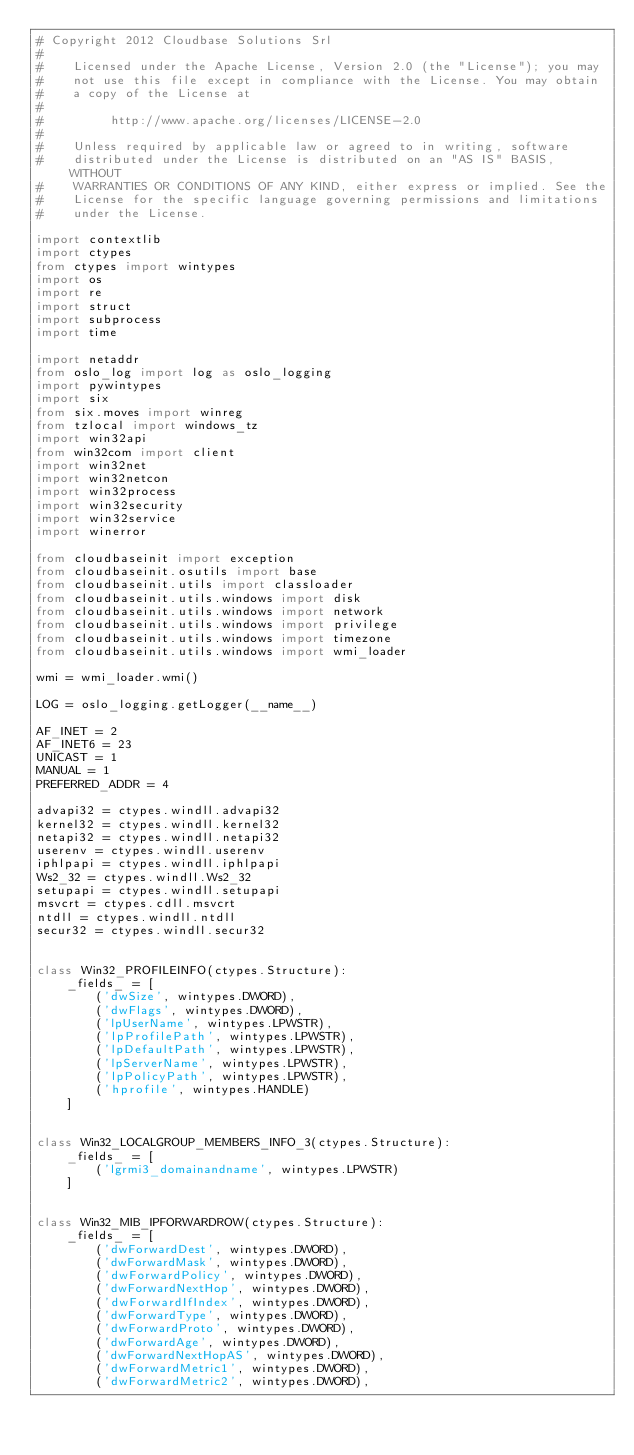<code> <loc_0><loc_0><loc_500><loc_500><_Python_># Copyright 2012 Cloudbase Solutions Srl
#
#    Licensed under the Apache License, Version 2.0 (the "License"); you may
#    not use this file except in compliance with the License. You may obtain
#    a copy of the License at
#
#         http://www.apache.org/licenses/LICENSE-2.0
#
#    Unless required by applicable law or agreed to in writing, software
#    distributed under the License is distributed on an "AS IS" BASIS, WITHOUT
#    WARRANTIES OR CONDITIONS OF ANY KIND, either express or implied. See the
#    License for the specific language governing permissions and limitations
#    under the License.

import contextlib
import ctypes
from ctypes import wintypes
import os
import re
import struct
import subprocess
import time

import netaddr
from oslo_log import log as oslo_logging
import pywintypes
import six
from six.moves import winreg
from tzlocal import windows_tz
import win32api
from win32com import client
import win32net
import win32netcon
import win32process
import win32security
import win32service
import winerror

from cloudbaseinit import exception
from cloudbaseinit.osutils import base
from cloudbaseinit.utils import classloader
from cloudbaseinit.utils.windows import disk
from cloudbaseinit.utils.windows import network
from cloudbaseinit.utils.windows import privilege
from cloudbaseinit.utils.windows import timezone
from cloudbaseinit.utils.windows import wmi_loader

wmi = wmi_loader.wmi()

LOG = oslo_logging.getLogger(__name__)

AF_INET = 2
AF_INET6 = 23
UNICAST = 1
MANUAL = 1
PREFERRED_ADDR = 4

advapi32 = ctypes.windll.advapi32
kernel32 = ctypes.windll.kernel32
netapi32 = ctypes.windll.netapi32
userenv = ctypes.windll.userenv
iphlpapi = ctypes.windll.iphlpapi
Ws2_32 = ctypes.windll.Ws2_32
setupapi = ctypes.windll.setupapi
msvcrt = ctypes.cdll.msvcrt
ntdll = ctypes.windll.ntdll
secur32 = ctypes.windll.secur32


class Win32_PROFILEINFO(ctypes.Structure):
    _fields_ = [
        ('dwSize', wintypes.DWORD),
        ('dwFlags', wintypes.DWORD),
        ('lpUserName', wintypes.LPWSTR),
        ('lpProfilePath', wintypes.LPWSTR),
        ('lpDefaultPath', wintypes.LPWSTR),
        ('lpServerName', wintypes.LPWSTR),
        ('lpPolicyPath', wintypes.LPWSTR),
        ('hprofile', wintypes.HANDLE)
    ]


class Win32_LOCALGROUP_MEMBERS_INFO_3(ctypes.Structure):
    _fields_ = [
        ('lgrmi3_domainandname', wintypes.LPWSTR)
    ]


class Win32_MIB_IPFORWARDROW(ctypes.Structure):
    _fields_ = [
        ('dwForwardDest', wintypes.DWORD),
        ('dwForwardMask', wintypes.DWORD),
        ('dwForwardPolicy', wintypes.DWORD),
        ('dwForwardNextHop', wintypes.DWORD),
        ('dwForwardIfIndex', wintypes.DWORD),
        ('dwForwardType', wintypes.DWORD),
        ('dwForwardProto', wintypes.DWORD),
        ('dwForwardAge', wintypes.DWORD),
        ('dwForwardNextHopAS', wintypes.DWORD),
        ('dwForwardMetric1', wintypes.DWORD),
        ('dwForwardMetric2', wintypes.DWORD),</code> 